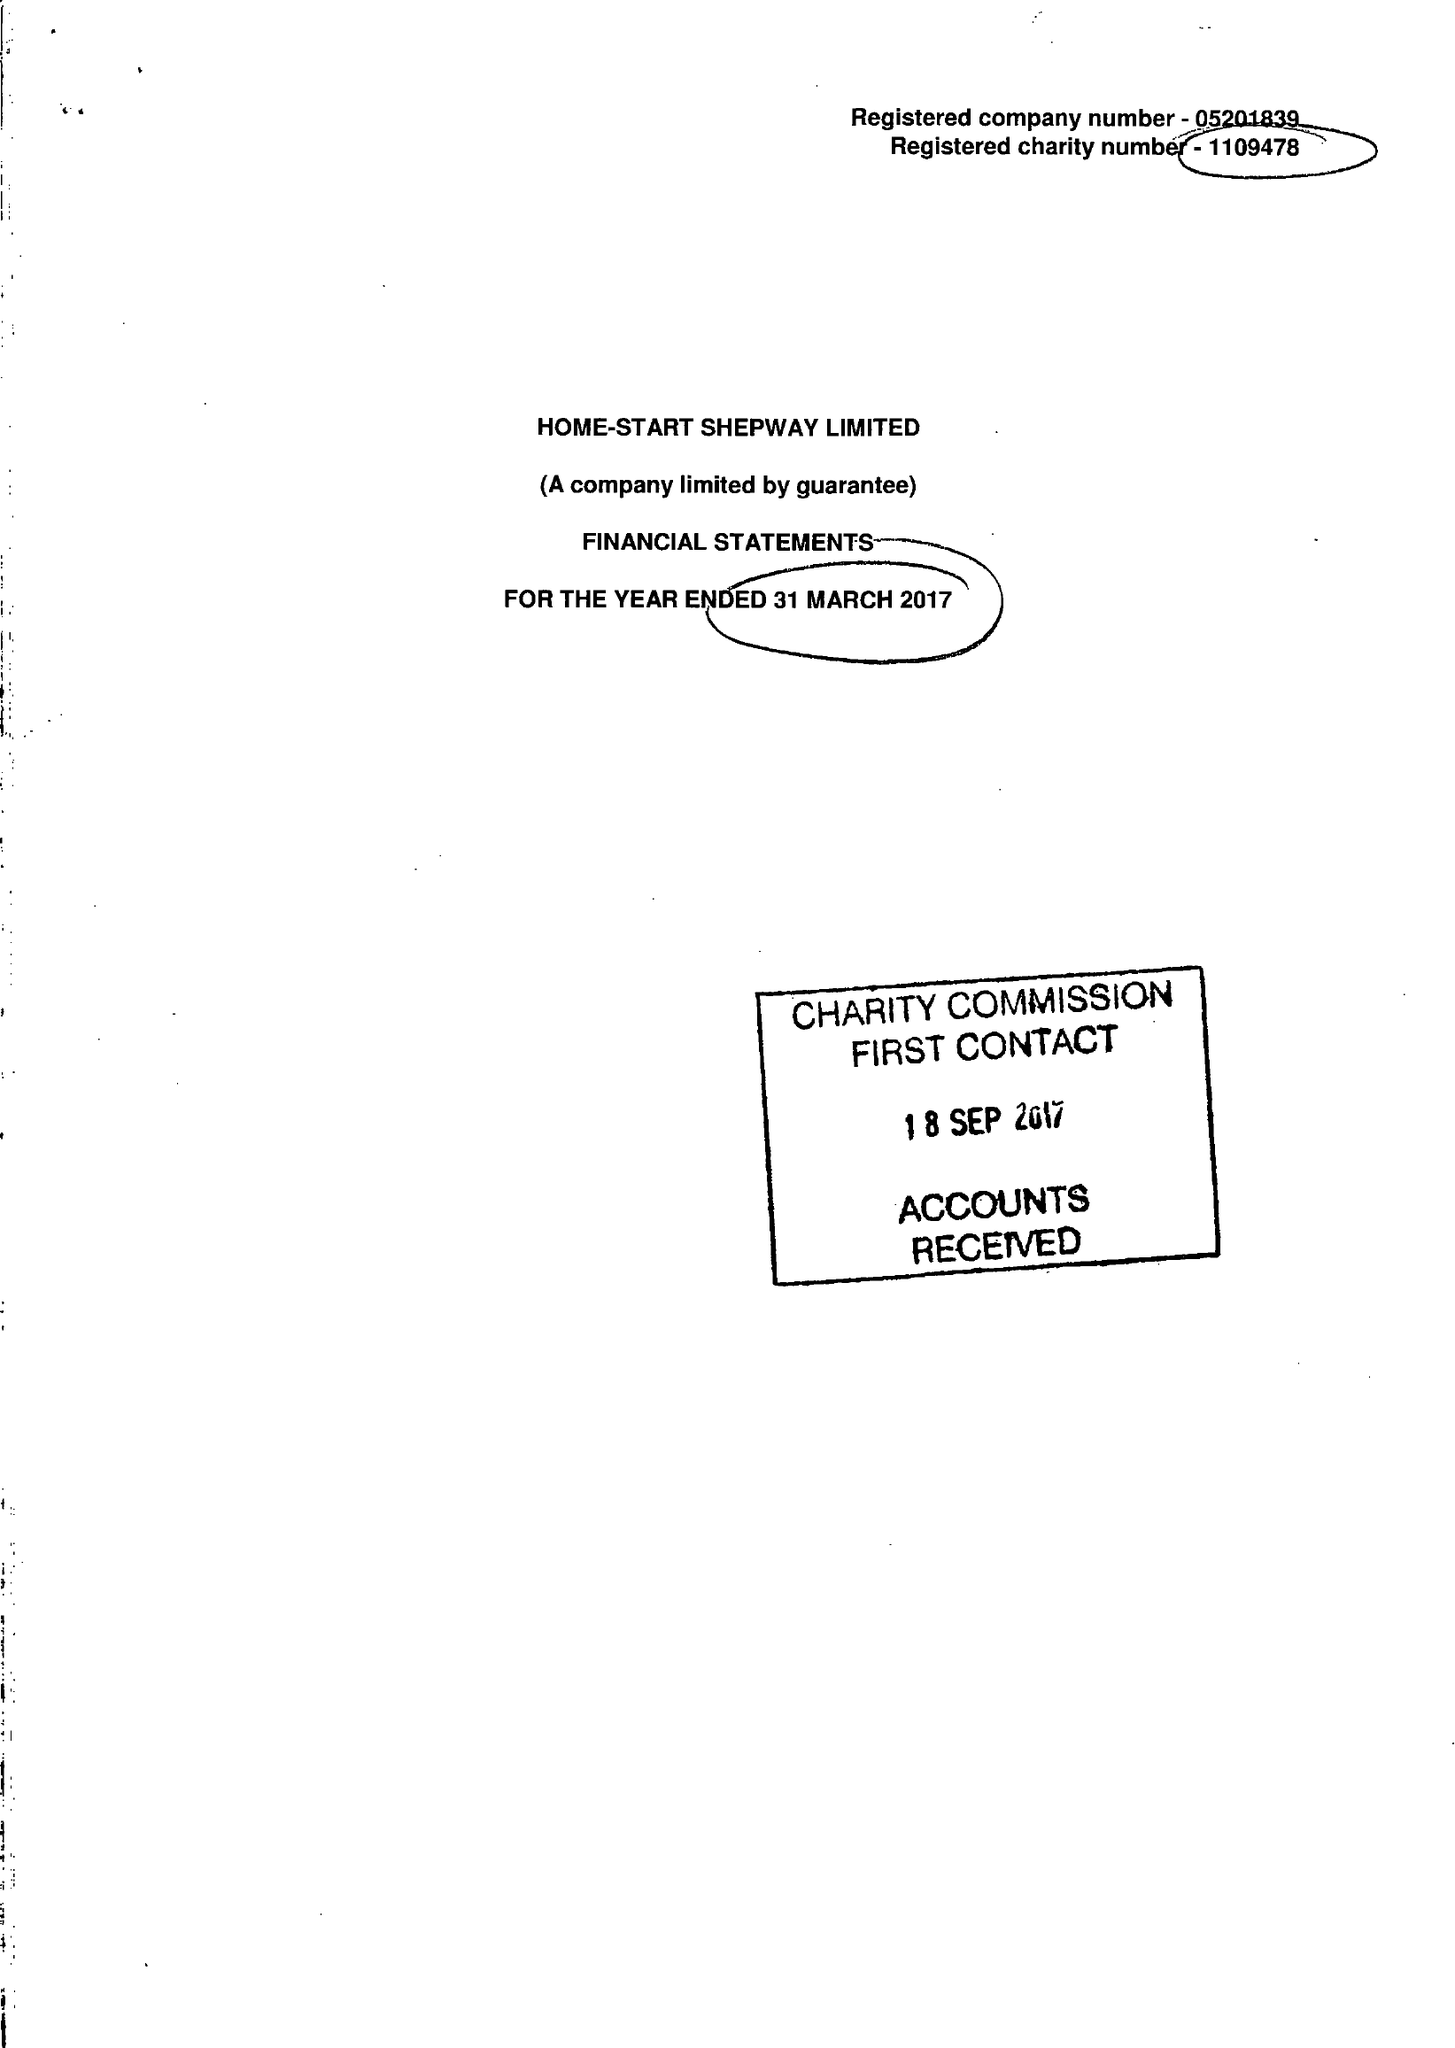What is the value for the address__postcode?
Answer the question using a single word or phrase. CT20 2AS 